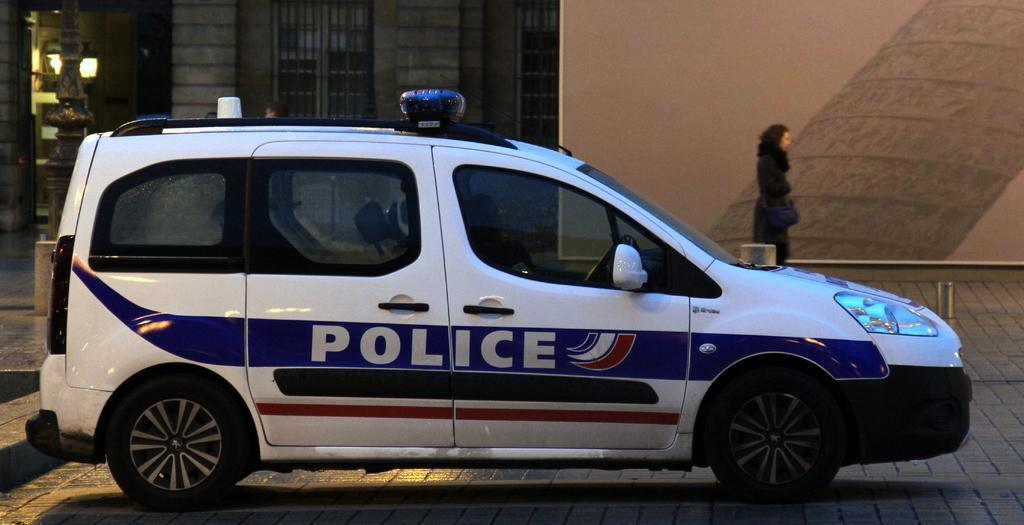Could you give a brief overview of what you see in this image? In the picture there is a police vehicle parked on a land and behind the vehicle there is some compartment and a woman is beside the wall on the right side. 